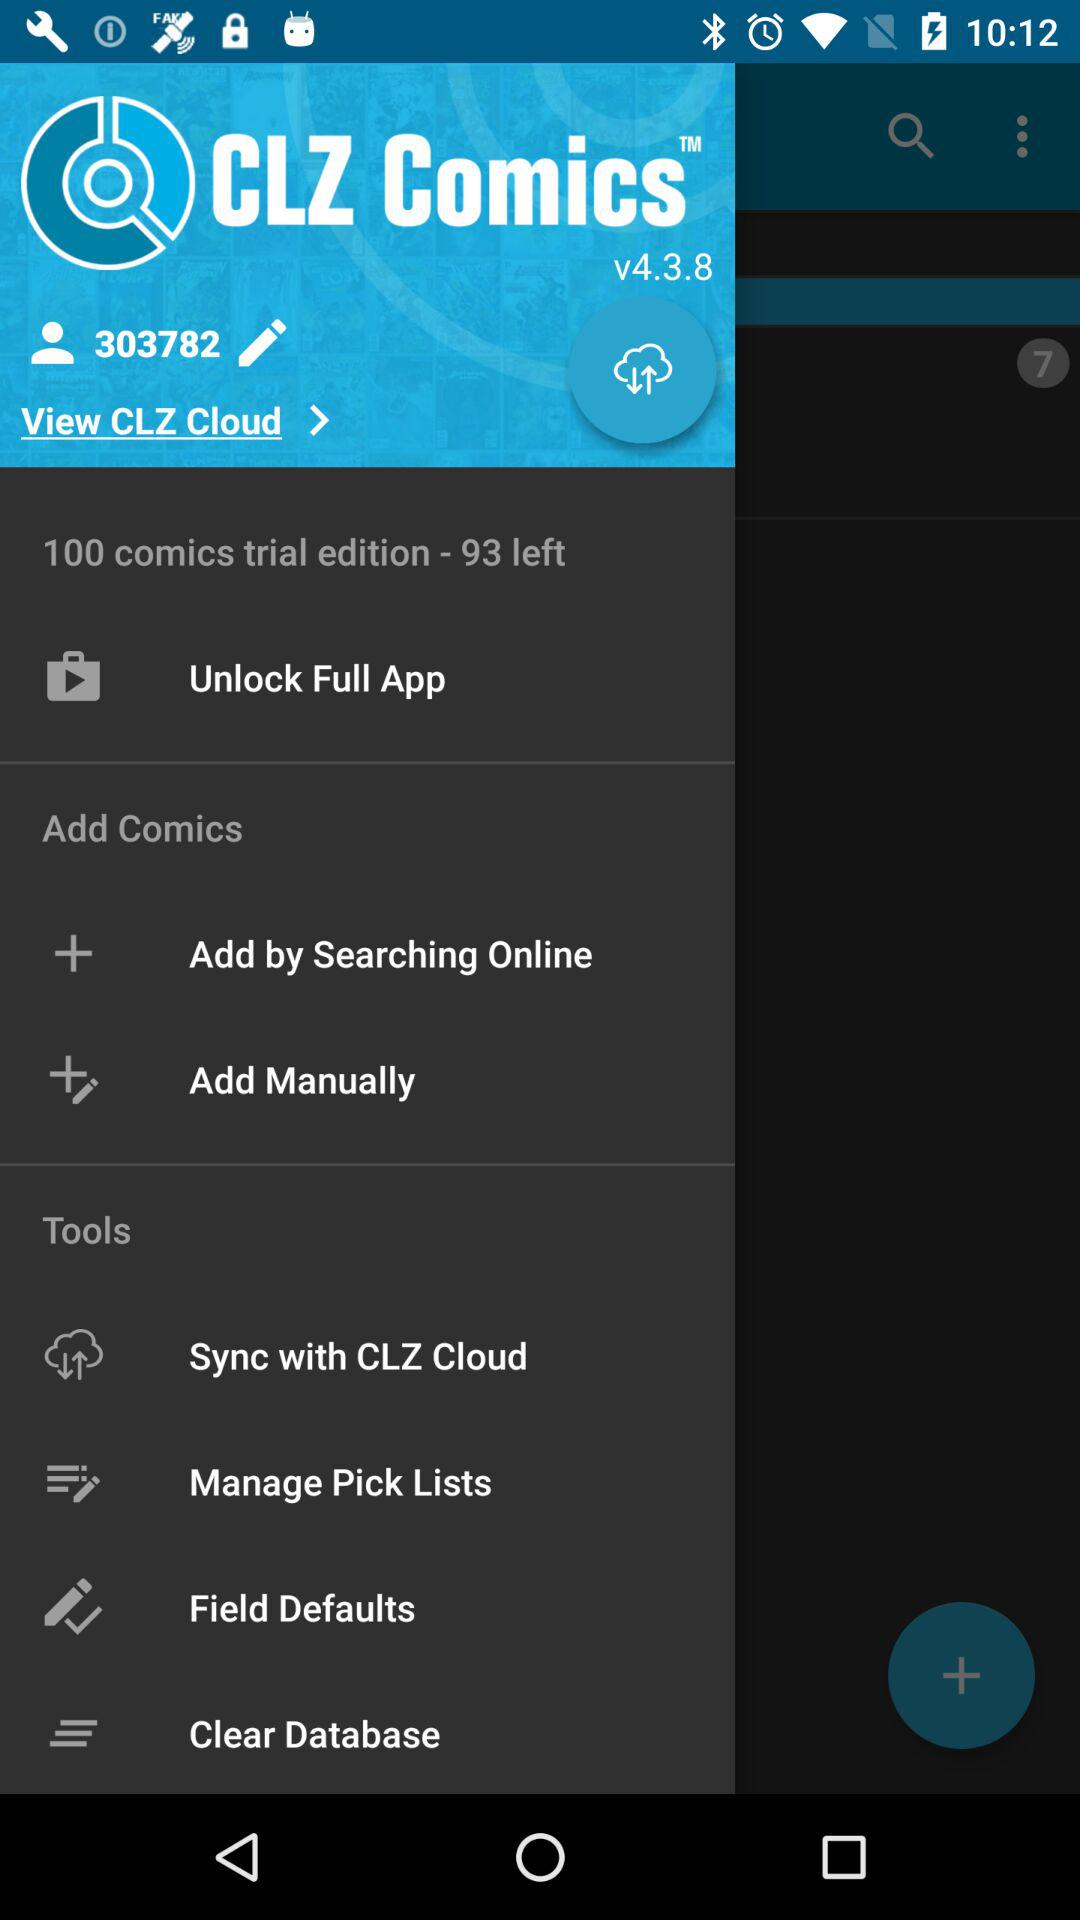What is the user ID? The user ID is 303782. 